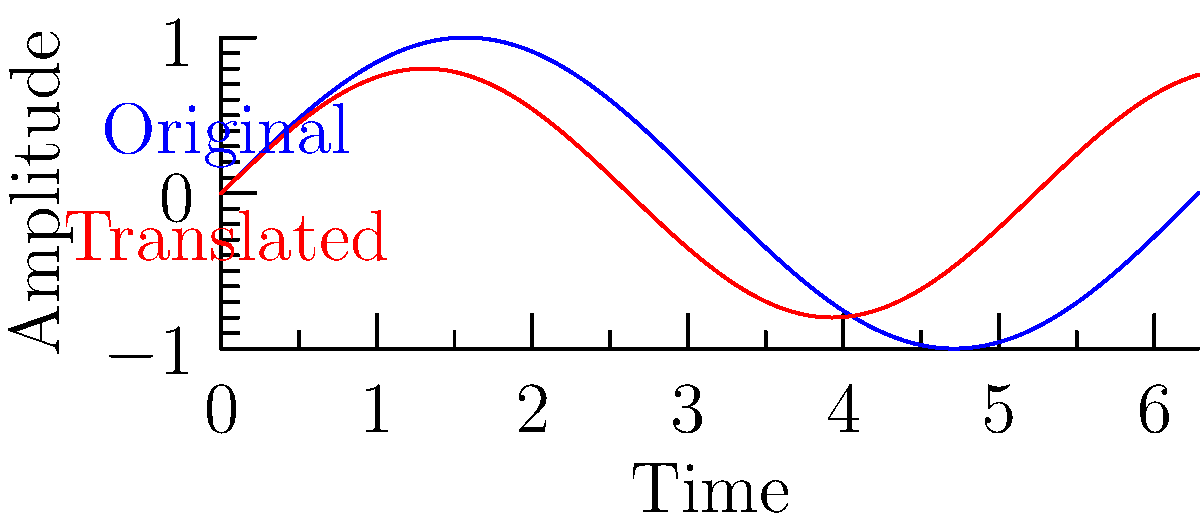In the context of translating K-pop lyrics while maintaining rhythm and meaning, which characteristic of the waveform visualization should be preserved to ensure the translated version matches the original song's tempo? To answer this question, let's analyze the waveform visualization and its relation to song translation:

1. The blue waveform represents the original song, while the red waveform represents the translated version.

2. In waveform visualizations:
   - The x-axis represents time
   - The y-axis represents amplitude (loudness)
   - The frequency of peaks and troughs represents the rhythm or tempo

3. To maintain the original song's tempo in the translated version:
   - The number of peaks and troughs should remain constant
   - The distance between peaks (or troughs) should be consistent

4. In the given visualization, we can observe that:
   - The red waveform has the same number of peaks and troughs as the blue waveform
   - The distance between peaks in the red waveform matches that of the blue waveform

5. This consistency in the frequency of peaks and troughs indicates that the tempo or rhythm is preserved in the translated version.

6. Therefore, to ensure the translated version matches the original song's tempo, the frequency of peaks and troughs in the waveform should be preserved.
Answer: Frequency of peaks and troughs 